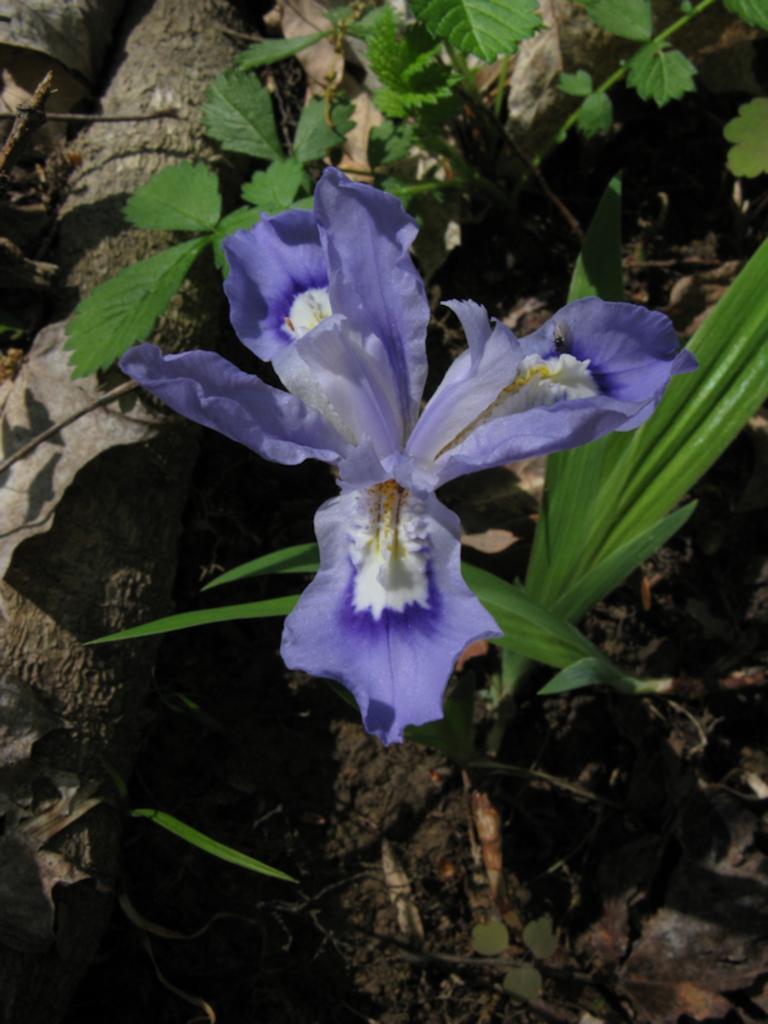Describe this image in one or two sentences. In this picture I can see the plants in front and I see the flowers which are of white and purple color. 